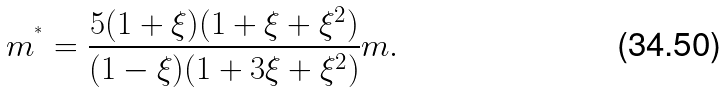<formula> <loc_0><loc_0><loc_500><loc_500>m ^ { ^ { * } } = \frac { 5 ( 1 + \xi ) ( 1 + \xi + \xi ^ { 2 } ) } { ( 1 - \xi ) ( 1 + 3 \xi + \xi ^ { 2 } ) } m .</formula> 